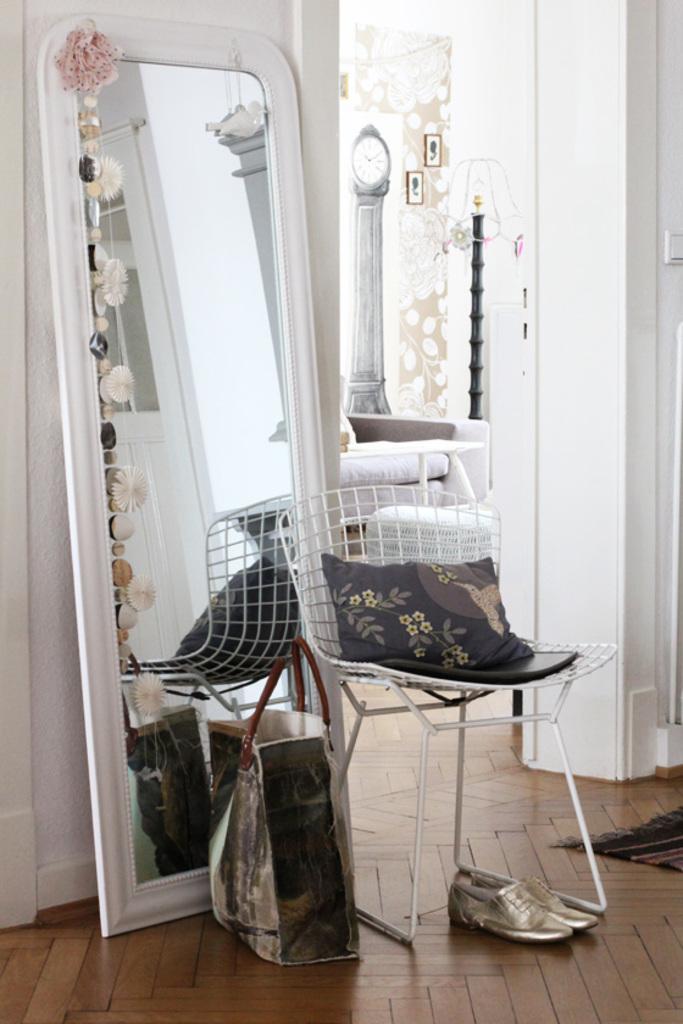In one or two sentences, can you explain what this image depicts? in this picture there is a mirror at the left side of the image and it is decorated from its corners, there is a chair at the center of the image and a pair of shoes under the chair, there is a rug at the right side of the image, there is a lamp and photographs at the center of the image in next room. 